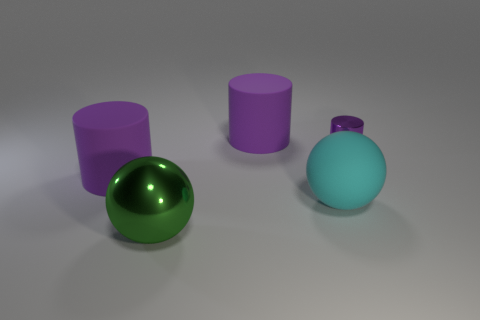Can you describe the positioning of the objects relative to each other? Certainly! In the image, we observe four objects in total. Starting with the purple cylinders, one is larger and stands to the right of the cyan sphere, while the other, smaller in size, is positioned further to the left. The green, shiny sphere is situated in the foreground, slightly to the left of the center of the scene, establishing a visually-balanced formation with the other objects. 